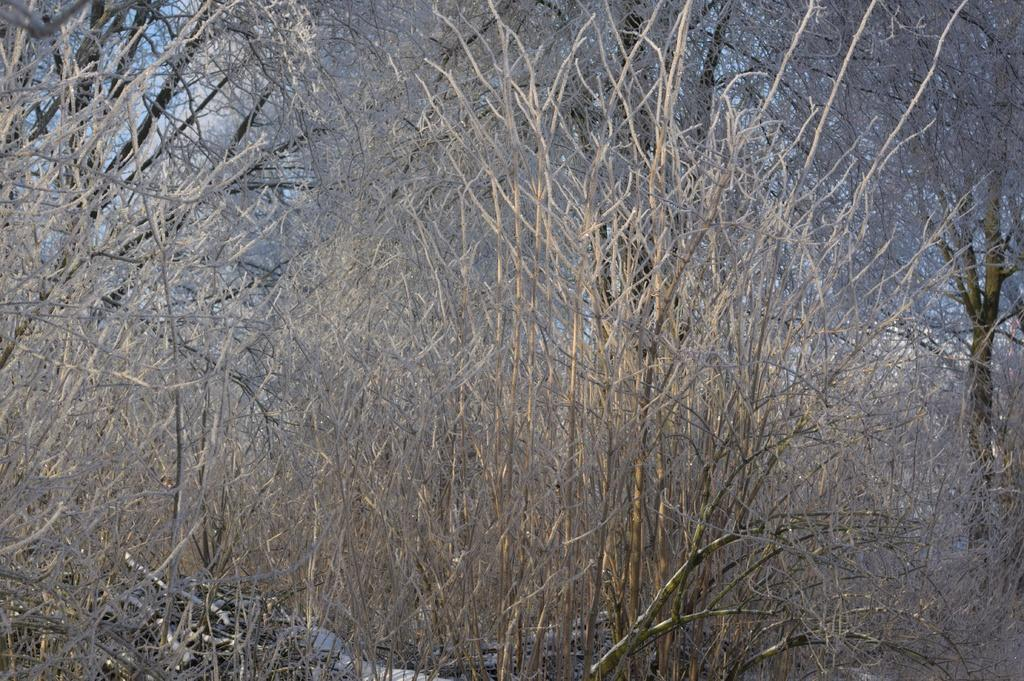What type of trees are in the image? The trees in the image are dried trees. What is the condition of the trees in the image? The trees have no leaves. What type of wren can be seen perched on the branches of the trees in the image? There are no wrens or any other birds visible in the image; the trees have no leaves and appear to be dried. 